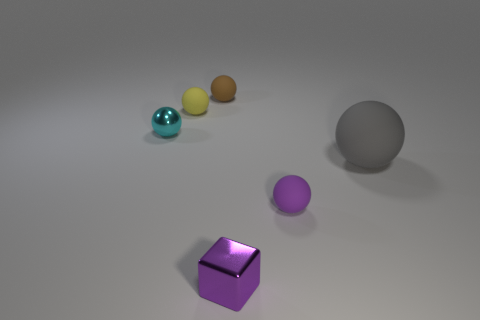Subtract all brown spheres. How many spheres are left? 4 Subtract all big rubber balls. How many balls are left? 4 Add 3 large yellow objects. How many objects exist? 9 Subtract all red balls. Subtract all cyan cylinders. How many balls are left? 5 Subtract all balls. How many objects are left? 1 Subtract all small gray blocks. Subtract all balls. How many objects are left? 1 Add 2 small cyan spheres. How many small cyan spheres are left? 3 Add 6 brown shiny cylinders. How many brown shiny cylinders exist? 6 Subtract 0 red blocks. How many objects are left? 6 